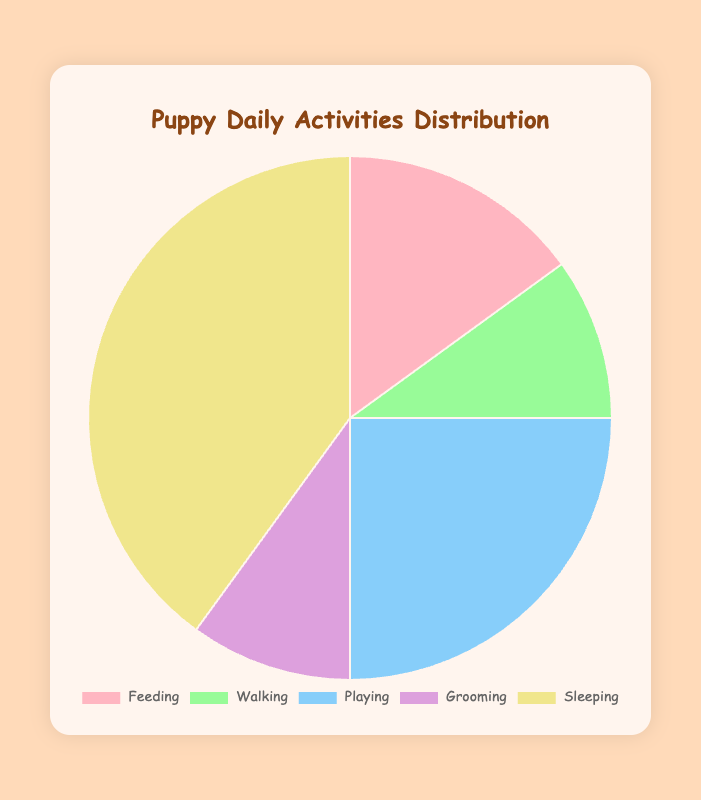Which activity takes up the most time for puppies? Look at the largest section of the pie chart. The section labeled "Sleeping" is the largest portion, indicating it takes up the most time.
Answer: Sleeping How much more time do puppies spend sleeping compared to walking? Subtract the percentage of time spent walking from the time spent sleeping. Sleeping is 40% and walking is 10%, so 40% - 10% = 30%.
Answer: 30% What percentage of the day do puppies spend feeding and grooming together? Add the percentages for feeding and grooming. Feeding is 15% and grooming is 10%, so 15% + 10% = 25%.
Answer: 25% Which activities take an equal amount of time in a puppy's day? Look for activities with the same percentage in the pie chart. Both walking and grooming take up 10% of the day each.
Answer: Walking and Grooming How many times greater is the percentage of time spent playing compared to walking? Divide the percentage of time spent playing by the percentage of time spent walking. Playing is 25% and walking is 10%, so 25% / 10% = 2.5 times.
Answer: 2.5 times Which activity is represented by the blue section of the pie chart? Identify the color assigned to each activity. The blue section corresponds to the "Playing" activity.
Answer: Playing What's the total percentage of time not spent sleeping? Subtract the percentage of time spent sleeping from 100%. Sleeping is 40%, so 100% - 40% = 60%.
Answer: 60% How does the time spent playing compare to the time spent feeding? Compare the percentages for playing and feeding. Playing (25%) is 10% more than feeding (15%).
Answer: 10% more What is the combined percentage of the smallest three activities? Identify the three smallest sections and sum their percentages. Walking, grooming, and feeding are 10%, 10%, and 15% respectively. So, 10% + 10% + 15% = 35%.
Answer: 35% What is the second most time-consuming activity for puppies? Identify the second largest section of the pie chart, which is the green section representing "Playing" at 25%.
Answer: Playing 